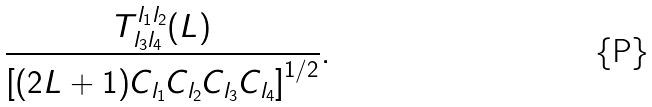<formula> <loc_0><loc_0><loc_500><loc_500>\frac { T ^ { l _ { 1 } l _ { 2 } } _ { l _ { 3 } l _ { 4 } } ( L ) } { \left [ ( 2 L + 1 ) C _ { l _ { 1 } } C _ { l _ { 2 } } C _ { l _ { 3 } } C _ { l _ { 4 } } \right ] ^ { 1 / 2 } } .</formula> 